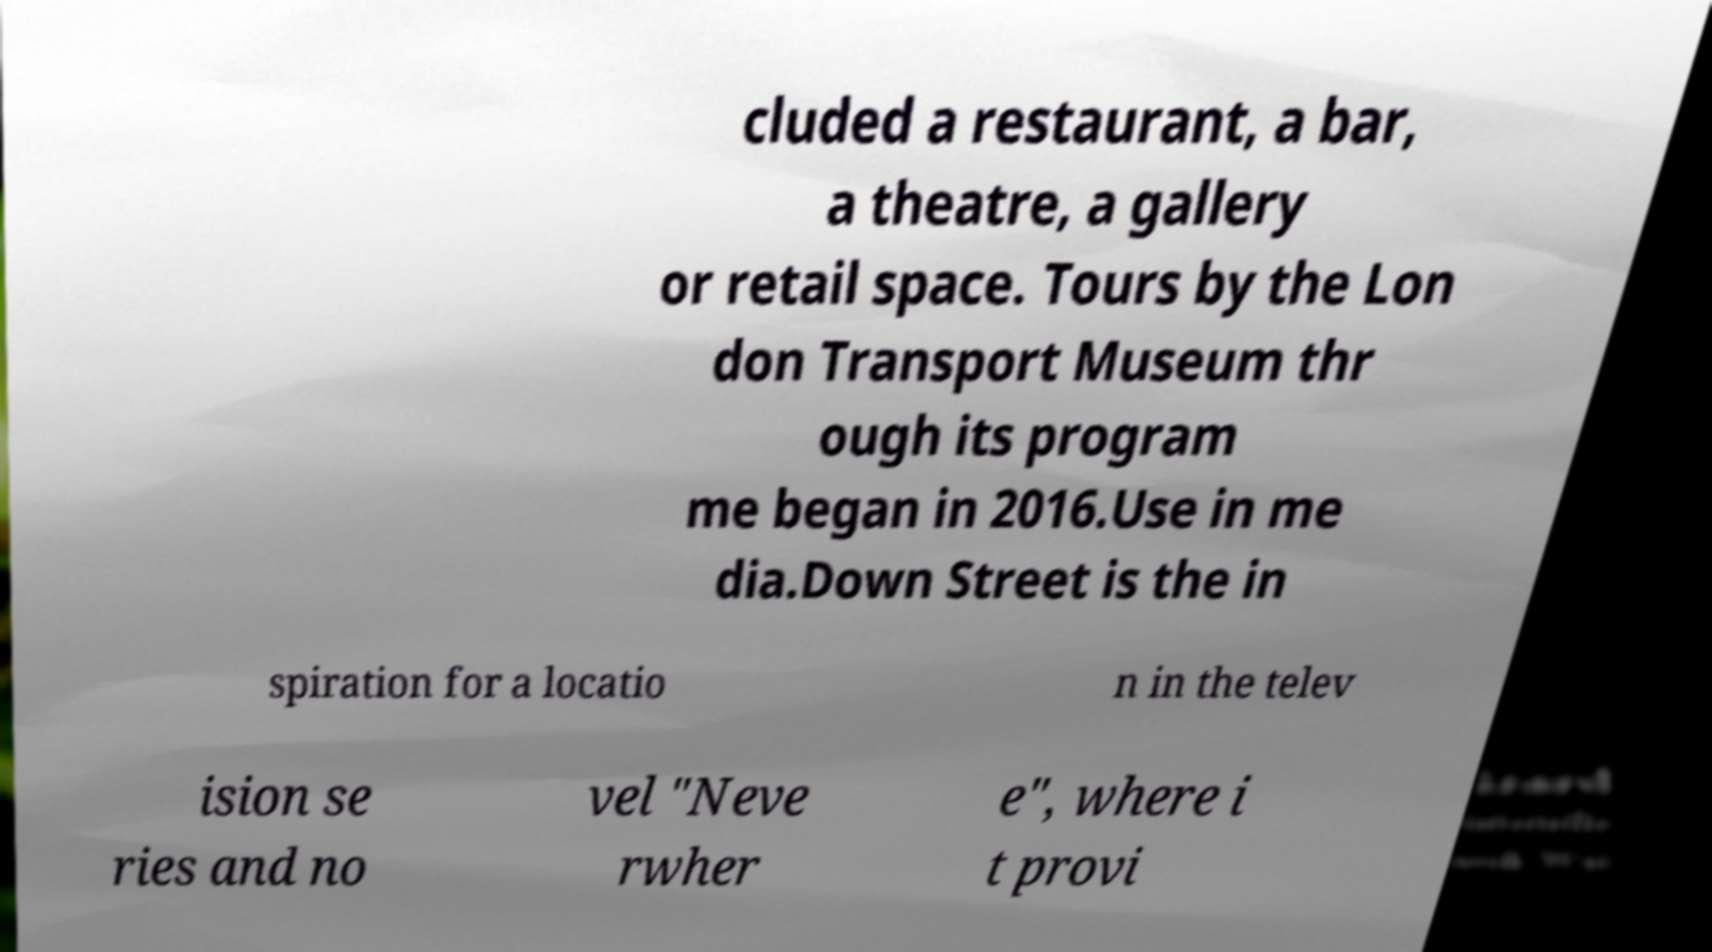Can you accurately transcribe the text from the provided image for me? cluded a restaurant, a bar, a theatre, a gallery or retail space. Tours by the Lon don Transport Museum thr ough its program me began in 2016.Use in me dia.Down Street is the in spiration for a locatio n in the telev ision se ries and no vel "Neve rwher e", where i t provi 